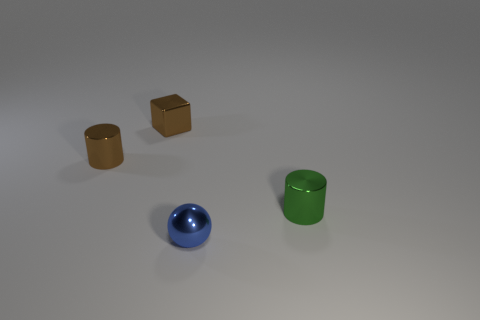Could you tell me the colors of the different objects in the image? Certainly! The image shows four distinct objects, each featuring its own unique color: there are two cubic blocks that sport a golden brown hue, suggesting a wooden texture. The two cylindrical objects are of different colors, one showcasing a shiny green tone, likely a painted metallic surface, and the other with a reflective blue, suggesting a similar metallic material with a colored finish. 